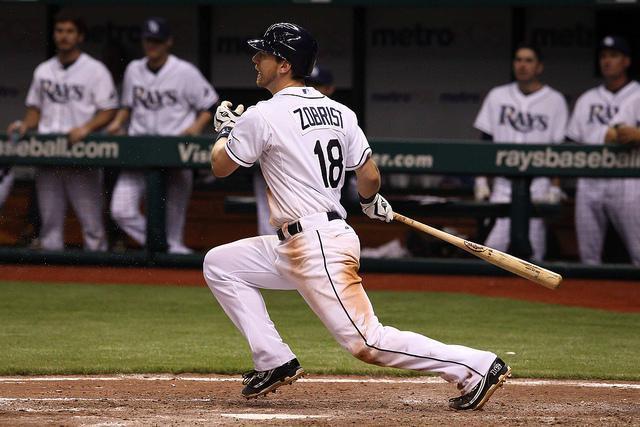How many people can be seen?
Give a very brief answer. 5. How many suitcases do you see?
Give a very brief answer. 0. 